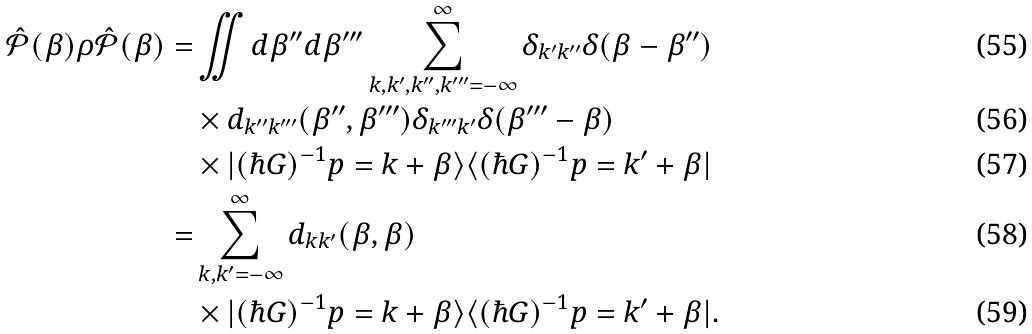<formula> <loc_0><loc_0><loc_500><loc_500>\hat { \mathcal { P } } ( \beta ) \rho \hat { \mathcal { P } } ( \beta ) = & \iint d \beta ^ { \prime \prime } d \beta ^ { \prime \prime \prime } \sum _ { k , k ^ { \prime } , k ^ { \prime \prime } , k ^ { \prime \prime \prime } = - \infty } ^ { \infty } \delta _ { k ^ { \prime } k ^ { \prime \prime } } \delta ( \beta - \beta ^ { \prime \prime } ) \\ & \times d _ { k ^ { \prime \prime } k ^ { \prime \prime \prime } } ( \beta ^ { \prime \prime } , \beta ^ { \prime \prime \prime } ) \delta _ { k ^ { \prime \prime \prime } k ^ { \prime } } \delta ( \beta ^ { \prime \prime \prime } - \beta ) \\ & \times | ( \hbar { G } ) ^ { - 1 } p = k + \beta \rangle \langle ( \hbar { G } ) ^ { - 1 } p = k ^ { \prime } + \beta | \\ = & \sum _ { k , k ^ { \prime } = - \infty } ^ { \infty } d _ { k k ^ { \prime } } ( \beta , \beta ) \\ & \times | ( \hbar { G } ) ^ { - 1 } p = k + \beta \rangle \langle ( \hbar { G } ) ^ { - 1 } p = k ^ { \prime } + \beta | .</formula> 